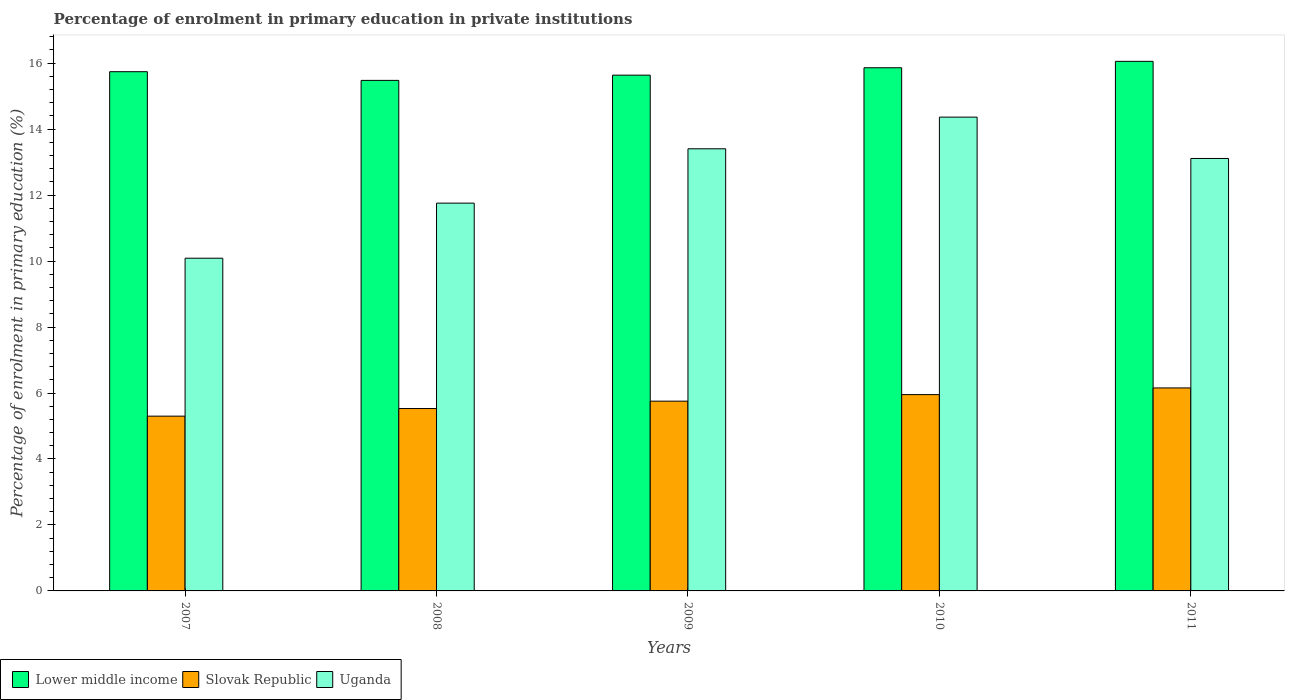How many different coloured bars are there?
Your response must be concise. 3. Are the number of bars per tick equal to the number of legend labels?
Offer a terse response. Yes. How many bars are there on the 1st tick from the right?
Your answer should be compact. 3. What is the percentage of enrolment in primary education in Lower middle income in 2007?
Your answer should be compact. 15.74. Across all years, what is the maximum percentage of enrolment in primary education in Slovak Republic?
Your answer should be very brief. 6.15. Across all years, what is the minimum percentage of enrolment in primary education in Slovak Republic?
Provide a succinct answer. 5.3. In which year was the percentage of enrolment in primary education in Uganda maximum?
Ensure brevity in your answer.  2010. What is the total percentage of enrolment in primary education in Lower middle income in the graph?
Your answer should be very brief. 78.77. What is the difference between the percentage of enrolment in primary education in Slovak Republic in 2008 and that in 2010?
Provide a short and direct response. -0.42. What is the difference between the percentage of enrolment in primary education in Lower middle income in 2008 and the percentage of enrolment in primary education in Slovak Republic in 2009?
Make the answer very short. 9.72. What is the average percentage of enrolment in primary education in Uganda per year?
Your answer should be very brief. 12.54. In the year 2011, what is the difference between the percentage of enrolment in primary education in Uganda and percentage of enrolment in primary education in Slovak Republic?
Your answer should be very brief. 6.96. In how many years, is the percentage of enrolment in primary education in Uganda greater than 6 %?
Keep it short and to the point. 5. What is the ratio of the percentage of enrolment in primary education in Uganda in 2008 to that in 2010?
Your answer should be very brief. 0.82. Is the percentage of enrolment in primary education in Uganda in 2008 less than that in 2010?
Provide a short and direct response. Yes. What is the difference between the highest and the second highest percentage of enrolment in primary education in Lower middle income?
Offer a terse response. 0.19. What is the difference between the highest and the lowest percentage of enrolment in primary education in Uganda?
Your answer should be very brief. 4.28. In how many years, is the percentage of enrolment in primary education in Uganda greater than the average percentage of enrolment in primary education in Uganda taken over all years?
Offer a very short reply. 3. What does the 2nd bar from the left in 2009 represents?
Your response must be concise. Slovak Republic. What does the 1st bar from the right in 2010 represents?
Give a very brief answer. Uganda. Is it the case that in every year, the sum of the percentage of enrolment in primary education in Slovak Republic and percentage of enrolment in primary education in Lower middle income is greater than the percentage of enrolment in primary education in Uganda?
Ensure brevity in your answer.  Yes. How many bars are there?
Your answer should be very brief. 15. Are the values on the major ticks of Y-axis written in scientific E-notation?
Provide a short and direct response. No. Does the graph contain any zero values?
Your answer should be compact. No. Does the graph contain grids?
Your answer should be very brief. No. Where does the legend appear in the graph?
Your answer should be compact. Bottom left. How many legend labels are there?
Provide a short and direct response. 3. How are the legend labels stacked?
Provide a short and direct response. Horizontal. What is the title of the graph?
Ensure brevity in your answer.  Percentage of enrolment in primary education in private institutions. Does "Belarus" appear as one of the legend labels in the graph?
Give a very brief answer. No. What is the label or title of the Y-axis?
Offer a terse response. Percentage of enrolment in primary education (%). What is the Percentage of enrolment in primary education (%) of Lower middle income in 2007?
Your answer should be compact. 15.74. What is the Percentage of enrolment in primary education (%) in Slovak Republic in 2007?
Your response must be concise. 5.3. What is the Percentage of enrolment in primary education (%) of Uganda in 2007?
Make the answer very short. 10.09. What is the Percentage of enrolment in primary education (%) of Lower middle income in 2008?
Give a very brief answer. 15.48. What is the Percentage of enrolment in primary education (%) of Slovak Republic in 2008?
Offer a terse response. 5.53. What is the Percentage of enrolment in primary education (%) in Uganda in 2008?
Your answer should be compact. 11.76. What is the Percentage of enrolment in primary education (%) of Lower middle income in 2009?
Your response must be concise. 15.64. What is the Percentage of enrolment in primary education (%) in Slovak Republic in 2009?
Keep it short and to the point. 5.75. What is the Percentage of enrolment in primary education (%) of Uganda in 2009?
Keep it short and to the point. 13.4. What is the Percentage of enrolment in primary education (%) in Lower middle income in 2010?
Your answer should be compact. 15.86. What is the Percentage of enrolment in primary education (%) in Slovak Republic in 2010?
Make the answer very short. 5.95. What is the Percentage of enrolment in primary education (%) of Uganda in 2010?
Give a very brief answer. 14.36. What is the Percentage of enrolment in primary education (%) of Lower middle income in 2011?
Offer a terse response. 16.05. What is the Percentage of enrolment in primary education (%) in Slovak Republic in 2011?
Ensure brevity in your answer.  6.15. What is the Percentage of enrolment in primary education (%) in Uganda in 2011?
Provide a succinct answer. 13.11. Across all years, what is the maximum Percentage of enrolment in primary education (%) in Lower middle income?
Offer a very short reply. 16.05. Across all years, what is the maximum Percentage of enrolment in primary education (%) in Slovak Republic?
Provide a short and direct response. 6.15. Across all years, what is the maximum Percentage of enrolment in primary education (%) of Uganda?
Offer a terse response. 14.36. Across all years, what is the minimum Percentage of enrolment in primary education (%) in Lower middle income?
Ensure brevity in your answer.  15.48. Across all years, what is the minimum Percentage of enrolment in primary education (%) in Slovak Republic?
Provide a short and direct response. 5.3. Across all years, what is the minimum Percentage of enrolment in primary education (%) of Uganda?
Offer a terse response. 10.09. What is the total Percentage of enrolment in primary education (%) in Lower middle income in the graph?
Make the answer very short. 78.77. What is the total Percentage of enrolment in primary education (%) in Slovak Republic in the graph?
Provide a succinct answer. 28.68. What is the total Percentage of enrolment in primary education (%) in Uganda in the graph?
Give a very brief answer. 62.72. What is the difference between the Percentage of enrolment in primary education (%) in Lower middle income in 2007 and that in 2008?
Make the answer very short. 0.26. What is the difference between the Percentage of enrolment in primary education (%) of Slovak Republic in 2007 and that in 2008?
Make the answer very short. -0.23. What is the difference between the Percentage of enrolment in primary education (%) in Uganda in 2007 and that in 2008?
Your answer should be very brief. -1.67. What is the difference between the Percentage of enrolment in primary education (%) of Lower middle income in 2007 and that in 2009?
Your answer should be compact. 0.1. What is the difference between the Percentage of enrolment in primary education (%) of Slovak Republic in 2007 and that in 2009?
Offer a very short reply. -0.45. What is the difference between the Percentage of enrolment in primary education (%) of Uganda in 2007 and that in 2009?
Ensure brevity in your answer.  -3.32. What is the difference between the Percentage of enrolment in primary education (%) of Lower middle income in 2007 and that in 2010?
Give a very brief answer. -0.12. What is the difference between the Percentage of enrolment in primary education (%) of Slovak Republic in 2007 and that in 2010?
Provide a short and direct response. -0.65. What is the difference between the Percentage of enrolment in primary education (%) of Uganda in 2007 and that in 2010?
Ensure brevity in your answer.  -4.28. What is the difference between the Percentage of enrolment in primary education (%) in Lower middle income in 2007 and that in 2011?
Keep it short and to the point. -0.31. What is the difference between the Percentage of enrolment in primary education (%) in Slovak Republic in 2007 and that in 2011?
Offer a terse response. -0.85. What is the difference between the Percentage of enrolment in primary education (%) in Uganda in 2007 and that in 2011?
Your answer should be very brief. -3.02. What is the difference between the Percentage of enrolment in primary education (%) in Lower middle income in 2008 and that in 2009?
Keep it short and to the point. -0.16. What is the difference between the Percentage of enrolment in primary education (%) in Slovak Republic in 2008 and that in 2009?
Your response must be concise. -0.22. What is the difference between the Percentage of enrolment in primary education (%) in Uganda in 2008 and that in 2009?
Your answer should be compact. -1.65. What is the difference between the Percentage of enrolment in primary education (%) of Lower middle income in 2008 and that in 2010?
Provide a short and direct response. -0.38. What is the difference between the Percentage of enrolment in primary education (%) of Slovak Republic in 2008 and that in 2010?
Offer a very short reply. -0.42. What is the difference between the Percentage of enrolment in primary education (%) of Uganda in 2008 and that in 2010?
Your answer should be compact. -2.61. What is the difference between the Percentage of enrolment in primary education (%) in Lower middle income in 2008 and that in 2011?
Provide a short and direct response. -0.58. What is the difference between the Percentage of enrolment in primary education (%) in Slovak Republic in 2008 and that in 2011?
Make the answer very short. -0.62. What is the difference between the Percentage of enrolment in primary education (%) of Uganda in 2008 and that in 2011?
Provide a succinct answer. -1.35. What is the difference between the Percentage of enrolment in primary education (%) of Lower middle income in 2009 and that in 2010?
Your answer should be compact. -0.22. What is the difference between the Percentage of enrolment in primary education (%) of Slovak Republic in 2009 and that in 2010?
Offer a terse response. -0.2. What is the difference between the Percentage of enrolment in primary education (%) in Uganda in 2009 and that in 2010?
Offer a terse response. -0.96. What is the difference between the Percentage of enrolment in primary education (%) in Lower middle income in 2009 and that in 2011?
Offer a very short reply. -0.42. What is the difference between the Percentage of enrolment in primary education (%) in Slovak Republic in 2009 and that in 2011?
Keep it short and to the point. -0.4. What is the difference between the Percentage of enrolment in primary education (%) in Uganda in 2009 and that in 2011?
Your response must be concise. 0.29. What is the difference between the Percentage of enrolment in primary education (%) of Lower middle income in 2010 and that in 2011?
Provide a short and direct response. -0.19. What is the difference between the Percentage of enrolment in primary education (%) in Slovak Republic in 2010 and that in 2011?
Your answer should be very brief. -0.2. What is the difference between the Percentage of enrolment in primary education (%) in Uganda in 2010 and that in 2011?
Give a very brief answer. 1.25. What is the difference between the Percentage of enrolment in primary education (%) of Lower middle income in 2007 and the Percentage of enrolment in primary education (%) of Slovak Republic in 2008?
Your response must be concise. 10.21. What is the difference between the Percentage of enrolment in primary education (%) of Lower middle income in 2007 and the Percentage of enrolment in primary education (%) of Uganda in 2008?
Your answer should be very brief. 3.98. What is the difference between the Percentage of enrolment in primary education (%) of Slovak Republic in 2007 and the Percentage of enrolment in primary education (%) of Uganda in 2008?
Your answer should be compact. -6.46. What is the difference between the Percentage of enrolment in primary education (%) in Lower middle income in 2007 and the Percentage of enrolment in primary education (%) in Slovak Republic in 2009?
Offer a terse response. 9.99. What is the difference between the Percentage of enrolment in primary education (%) of Lower middle income in 2007 and the Percentage of enrolment in primary education (%) of Uganda in 2009?
Provide a short and direct response. 2.34. What is the difference between the Percentage of enrolment in primary education (%) of Slovak Republic in 2007 and the Percentage of enrolment in primary education (%) of Uganda in 2009?
Offer a terse response. -8.11. What is the difference between the Percentage of enrolment in primary education (%) in Lower middle income in 2007 and the Percentage of enrolment in primary education (%) in Slovak Republic in 2010?
Offer a terse response. 9.79. What is the difference between the Percentage of enrolment in primary education (%) in Lower middle income in 2007 and the Percentage of enrolment in primary education (%) in Uganda in 2010?
Offer a terse response. 1.38. What is the difference between the Percentage of enrolment in primary education (%) in Slovak Republic in 2007 and the Percentage of enrolment in primary education (%) in Uganda in 2010?
Your answer should be compact. -9.06. What is the difference between the Percentage of enrolment in primary education (%) in Lower middle income in 2007 and the Percentage of enrolment in primary education (%) in Slovak Republic in 2011?
Ensure brevity in your answer.  9.59. What is the difference between the Percentage of enrolment in primary education (%) of Lower middle income in 2007 and the Percentage of enrolment in primary education (%) of Uganda in 2011?
Your response must be concise. 2.63. What is the difference between the Percentage of enrolment in primary education (%) of Slovak Republic in 2007 and the Percentage of enrolment in primary education (%) of Uganda in 2011?
Make the answer very short. -7.81. What is the difference between the Percentage of enrolment in primary education (%) in Lower middle income in 2008 and the Percentage of enrolment in primary education (%) in Slovak Republic in 2009?
Your answer should be very brief. 9.72. What is the difference between the Percentage of enrolment in primary education (%) in Lower middle income in 2008 and the Percentage of enrolment in primary education (%) in Uganda in 2009?
Provide a short and direct response. 2.07. What is the difference between the Percentage of enrolment in primary education (%) in Slovak Republic in 2008 and the Percentage of enrolment in primary education (%) in Uganda in 2009?
Provide a succinct answer. -7.87. What is the difference between the Percentage of enrolment in primary education (%) in Lower middle income in 2008 and the Percentage of enrolment in primary education (%) in Slovak Republic in 2010?
Provide a short and direct response. 9.53. What is the difference between the Percentage of enrolment in primary education (%) in Lower middle income in 2008 and the Percentage of enrolment in primary education (%) in Uganda in 2010?
Offer a terse response. 1.11. What is the difference between the Percentage of enrolment in primary education (%) in Slovak Republic in 2008 and the Percentage of enrolment in primary education (%) in Uganda in 2010?
Your response must be concise. -8.83. What is the difference between the Percentage of enrolment in primary education (%) in Lower middle income in 2008 and the Percentage of enrolment in primary education (%) in Slovak Republic in 2011?
Your answer should be compact. 9.32. What is the difference between the Percentage of enrolment in primary education (%) of Lower middle income in 2008 and the Percentage of enrolment in primary education (%) of Uganda in 2011?
Provide a short and direct response. 2.37. What is the difference between the Percentage of enrolment in primary education (%) of Slovak Republic in 2008 and the Percentage of enrolment in primary education (%) of Uganda in 2011?
Provide a succinct answer. -7.58. What is the difference between the Percentage of enrolment in primary education (%) in Lower middle income in 2009 and the Percentage of enrolment in primary education (%) in Slovak Republic in 2010?
Give a very brief answer. 9.68. What is the difference between the Percentage of enrolment in primary education (%) in Lower middle income in 2009 and the Percentage of enrolment in primary education (%) in Uganda in 2010?
Keep it short and to the point. 1.27. What is the difference between the Percentage of enrolment in primary education (%) in Slovak Republic in 2009 and the Percentage of enrolment in primary education (%) in Uganda in 2010?
Provide a short and direct response. -8.61. What is the difference between the Percentage of enrolment in primary education (%) of Lower middle income in 2009 and the Percentage of enrolment in primary education (%) of Slovak Republic in 2011?
Make the answer very short. 9.48. What is the difference between the Percentage of enrolment in primary education (%) of Lower middle income in 2009 and the Percentage of enrolment in primary education (%) of Uganda in 2011?
Provide a short and direct response. 2.53. What is the difference between the Percentage of enrolment in primary education (%) of Slovak Republic in 2009 and the Percentage of enrolment in primary education (%) of Uganda in 2011?
Your response must be concise. -7.36. What is the difference between the Percentage of enrolment in primary education (%) in Lower middle income in 2010 and the Percentage of enrolment in primary education (%) in Slovak Republic in 2011?
Your answer should be very brief. 9.71. What is the difference between the Percentage of enrolment in primary education (%) in Lower middle income in 2010 and the Percentage of enrolment in primary education (%) in Uganda in 2011?
Your answer should be compact. 2.75. What is the difference between the Percentage of enrolment in primary education (%) of Slovak Republic in 2010 and the Percentage of enrolment in primary education (%) of Uganda in 2011?
Give a very brief answer. -7.16. What is the average Percentage of enrolment in primary education (%) in Lower middle income per year?
Your answer should be compact. 15.75. What is the average Percentage of enrolment in primary education (%) in Slovak Republic per year?
Ensure brevity in your answer.  5.74. What is the average Percentage of enrolment in primary education (%) of Uganda per year?
Your answer should be very brief. 12.54. In the year 2007, what is the difference between the Percentage of enrolment in primary education (%) of Lower middle income and Percentage of enrolment in primary education (%) of Slovak Republic?
Give a very brief answer. 10.44. In the year 2007, what is the difference between the Percentage of enrolment in primary education (%) in Lower middle income and Percentage of enrolment in primary education (%) in Uganda?
Ensure brevity in your answer.  5.65. In the year 2007, what is the difference between the Percentage of enrolment in primary education (%) of Slovak Republic and Percentage of enrolment in primary education (%) of Uganda?
Keep it short and to the point. -4.79. In the year 2008, what is the difference between the Percentage of enrolment in primary education (%) in Lower middle income and Percentage of enrolment in primary education (%) in Slovak Republic?
Your answer should be compact. 9.95. In the year 2008, what is the difference between the Percentage of enrolment in primary education (%) of Lower middle income and Percentage of enrolment in primary education (%) of Uganda?
Give a very brief answer. 3.72. In the year 2008, what is the difference between the Percentage of enrolment in primary education (%) of Slovak Republic and Percentage of enrolment in primary education (%) of Uganda?
Provide a short and direct response. -6.23. In the year 2009, what is the difference between the Percentage of enrolment in primary education (%) in Lower middle income and Percentage of enrolment in primary education (%) in Slovak Republic?
Offer a very short reply. 9.88. In the year 2009, what is the difference between the Percentage of enrolment in primary education (%) in Lower middle income and Percentage of enrolment in primary education (%) in Uganda?
Offer a terse response. 2.23. In the year 2009, what is the difference between the Percentage of enrolment in primary education (%) of Slovak Republic and Percentage of enrolment in primary education (%) of Uganda?
Keep it short and to the point. -7.65. In the year 2010, what is the difference between the Percentage of enrolment in primary education (%) of Lower middle income and Percentage of enrolment in primary education (%) of Slovak Republic?
Your answer should be compact. 9.91. In the year 2010, what is the difference between the Percentage of enrolment in primary education (%) of Lower middle income and Percentage of enrolment in primary education (%) of Uganda?
Provide a short and direct response. 1.5. In the year 2010, what is the difference between the Percentage of enrolment in primary education (%) in Slovak Republic and Percentage of enrolment in primary education (%) in Uganda?
Your answer should be very brief. -8.41. In the year 2011, what is the difference between the Percentage of enrolment in primary education (%) in Lower middle income and Percentage of enrolment in primary education (%) in Slovak Republic?
Offer a terse response. 9.9. In the year 2011, what is the difference between the Percentage of enrolment in primary education (%) in Lower middle income and Percentage of enrolment in primary education (%) in Uganda?
Offer a terse response. 2.94. In the year 2011, what is the difference between the Percentage of enrolment in primary education (%) of Slovak Republic and Percentage of enrolment in primary education (%) of Uganda?
Your response must be concise. -6.96. What is the ratio of the Percentage of enrolment in primary education (%) in Slovak Republic in 2007 to that in 2008?
Keep it short and to the point. 0.96. What is the ratio of the Percentage of enrolment in primary education (%) in Uganda in 2007 to that in 2008?
Provide a succinct answer. 0.86. What is the ratio of the Percentage of enrolment in primary education (%) in Lower middle income in 2007 to that in 2009?
Make the answer very short. 1.01. What is the ratio of the Percentage of enrolment in primary education (%) of Slovak Republic in 2007 to that in 2009?
Ensure brevity in your answer.  0.92. What is the ratio of the Percentage of enrolment in primary education (%) in Uganda in 2007 to that in 2009?
Offer a very short reply. 0.75. What is the ratio of the Percentage of enrolment in primary education (%) in Lower middle income in 2007 to that in 2010?
Offer a terse response. 0.99. What is the ratio of the Percentage of enrolment in primary education (%) of Slovak Republic in 2007 to that in 2010?
Offer a very short reply. 0.89. What is the ratio of the Percentage of enrolment in primary education (%) of Uganda in 2007 to that in 2010?
Your response must be concise. 0.7. What is the ratio of the Percentage of enrolment in primary education (%) in Lower middle income in 2007 to that in 2011?
Your answer should be very brief. 0.98. What is the ratio of the Percentage of enrolment in primary education (%) in Slovak Republic in 2007 to that in 2011?
Offer a very short reply. 0.86. What is the ratio of the Percentage of enrolment in primary education (%) of Uganda in 2007 to that in 2011?
Offer a very short reply. 0.77. What is the ratio of the Percentage of enrolment in primary education (%) of Lower middle income in 2008 to that in 2009?
Your answer should be compact. 0.99. What is the ratio of the Percentage of enrolment in primary education (%) of Slovak Republic in 2008 to that in 2009?
Provide a short and direct response. 0.96. What is the ratio of the Percentage of enrolment in primary education (%) in Uganda in 2008 to that in 2009?
Offer a very short reply. 0.88. What is the ratio of the Percentage of enrolment in primary education (%) in Lower middle income in 2008 to that in 2010?
Provide a short and direct response. 0.98. What is the ratio of the Percentage of enrolment in primary education (%) of Slovak Republic in 2008 to that in 2010?
Keep it short and to the point. 0.93. What is the ratio of the Percentage of enrolment in primary education (%) in Uganda in 2008 to that in 2010?
Offer a very short reply. 0.82. What is the ratio of the Percentage of enrolment in primary education (%) in Lower middle income in 2008 to that in 2011?
Give a very brief answer. 0.96. What is the ratio of the Percentage of enrolment in primary education (%) in Slovak Republic in 2008 to that in 2011?
Provide a short and direct response. 0.9. What is the ratio of the Percentage of enrolment in primary education (%) in Uganda in 2008 to that in 2011?
Your answer should be very brief. 0.9. What is the ratio of the Percentage of enrolment in primary education (%) in Lower middle income in 2009 to that in 2010?
Your response must be concise. 0.99. What is the ratio of the Percentage of enrolment in primary education (%) of Slovak Republic in 2009 to that in 2010?
Your response must be concise. 0.97. What is the ratio of the Percentage of enrolment in primary education (%) of Uganda in 2009 to that in 2010?
Offer a very short reply. 0.93. What is the ratio of the Percentage of enrolment in primary education (%) of Lower middle income in 2009 to that in 2011?
Make the answer very short. 0.97. What is the ratio of the Percentage of enrolment in primary education (%) of Slovak Republic in 2009 to that in 2011?
Provide a succinct answer. 0.93. What is the ratio of the Percentage of enrolment in primary education (%) of Uganda in 2009 to that in 2011?
Give a very brief answer. 1.02. What is the ratio of the Percentage of enrolment in primary education (%) of Lower middle income in 2010 to that in 2011?
Your answer should be compact. 0.99. What is the ratio of the Percentage of enrolment in primary education (%) of Slovak Republic in 2010 to that in 2011?
Offer a very short reply. 0.97. What is the ratio of the Percentage of enrolment in primary education (%) in Uganda in 2010 to that in 2011?
Offer a terse response. 1.1. What is the difference between the highest and the second highest Percentage of enrolment in primary education (%) of Lower middle income?
Offer a very short reply. 0.19. What is the difference between the highest and the second highest Percentage of enrolment in primary education (%) of Slovak Republic?
Offer a very short reply. 0.2. What is the difference between the highest and the lowest Percentage of enrolment in primary education (%) of Lower middle income?
Offer a terse response. 0.58. What is the difference between the highest and the lowest Percentage of enrolment in primary education (%) in Slovak Republic?
Ensure brevity in your answer.  0.85. What is the difference between the highest and the lowest Percentage of enrolment in primary education (%) in Uganda?
Your answer should be compact. 4.28. 